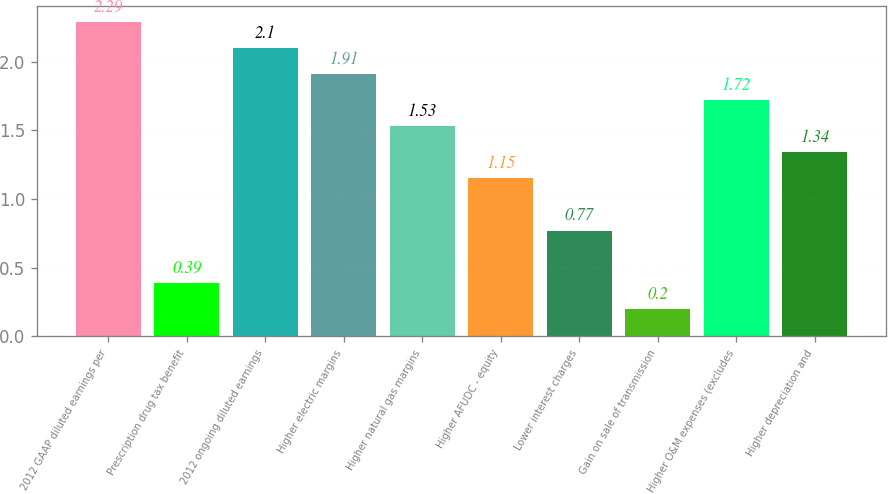<chart> <loc_0><loc_0><loc_500><loc_500><bar_chart><fcel>2012 GAAP diluted earnings per<fcel>Prescription drug tax benefit<fcel>2012 ongoing diluted earnings<fcel>Higher electric margins<fcel>Higher natural gas margins<fcel>Higher AFUDC - equity<fcel>Lower interest charges<fcel>Gain on sale of transmission<fcel>Higher O&M expenses (excludes<fcel>Higher depreciation and<nl><fcel>2.29<fcel>0.39<fcel>2.1<fcel>1.91<fcel>1.53<fcel>1.15<fcel>0.77<fcel>0.2<fcel>1.72<fcel>1.34<nl></chart> 